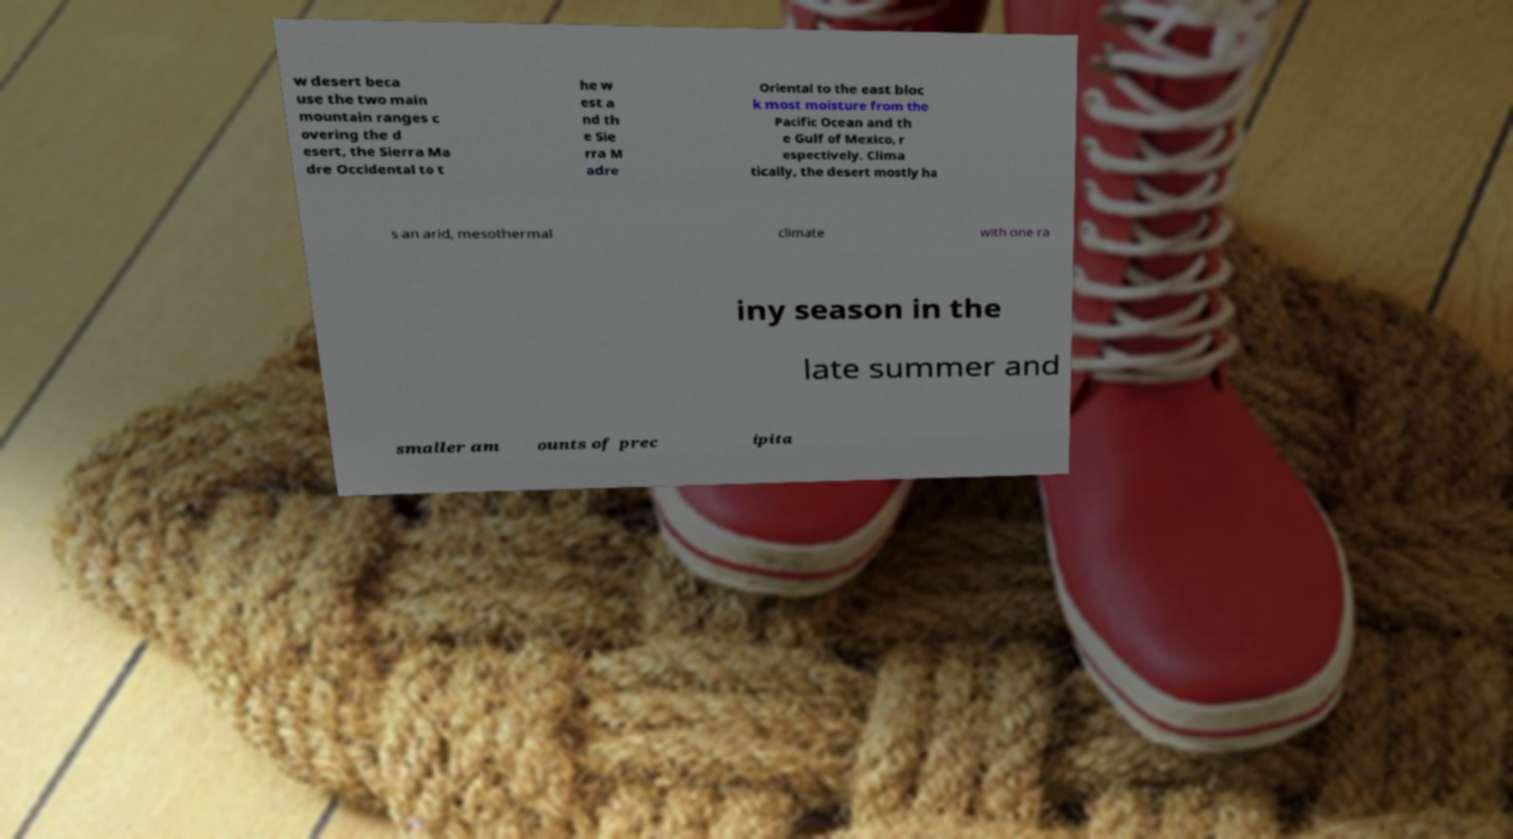What messages or text are displayed in this image? I need them in a readable, typed format. w desert beca use the two main mountain ranges c overing the d esert, the Sierra Ma dre Occidental to t he w est a nd th e Sie rra M adre Oriental to the east bloc k most moisture from the Pacific Ocean and th e Gulf of Mexico, r espectively. Clima tically, the desert mostly ha s an arid, mesothermal climate with one ra iny season in the late summer and smaller am ounts of prec ipita 